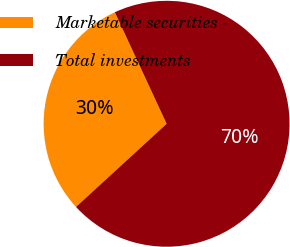Convert chart to OTSL. <chart><loc_0><loc_0><loc_500><loc_500><pie_chart><fcel>Marketable securities -<fcel>Total investments<nl><fcel>29.9%<fcel>70.1%<nl></chart> 